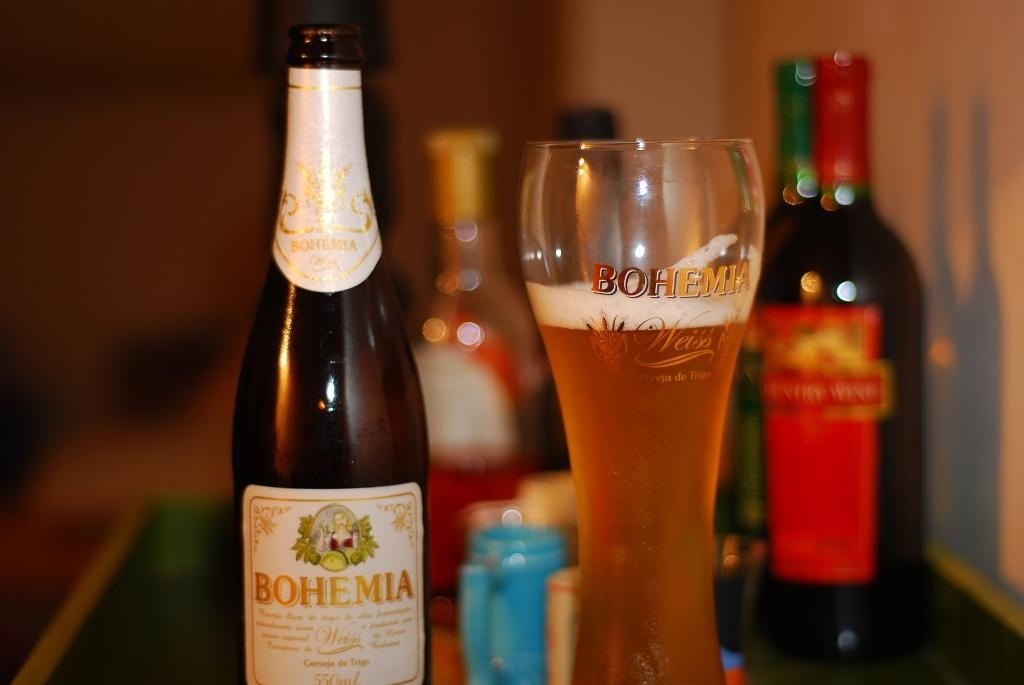<image>
Provide a brief description of the given image. A bottle of bohemia branded alcohol with a glass that has the same brand on it. 